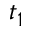<formula> <loc_0><loc_0><loc_500><loc_500>t _ { 1 }</formula> 